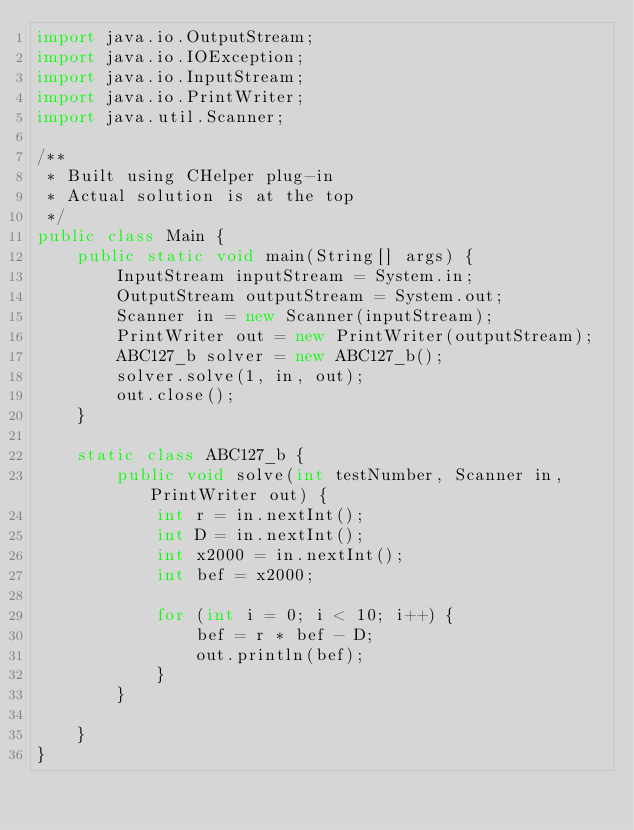<code> <loc_0><loc_0><loc_500><loc_500><_Java_>import java.io.OutputStream;
import java.io.IOException;
import java.io.InputStream;
import java.io.PrintWriter;
import java.util.Scanner;

/**
 * Built using CHelper plug-in
 * Actual solution is at the top
 */
public class Main {
    public static void main(String[] args) {
        InputStream inputStream = System.in;
        OutputStream outputStream = System.out;
        Scanner in = new Scanner(inputStream);
        PrintWriter out = new PrintWriter(outputStream);
        ABC127_b solver = new ABC127_b();
        solver.solve(1, in, out);
        out.close();
    }

    static class ABC127_b {
        public void solve(int testNumber, Scanner in, PrintWriter out) {
            int r = in.nextInt();
            int D = in.nextInt();
            int x2000 = in.nextInt();
            int bef = x2000;

            for (int i = 0; i < 10; i++) {
                bef = r * bef - D;
                out.println(bef);
            }
        }

    }
}

</code> 